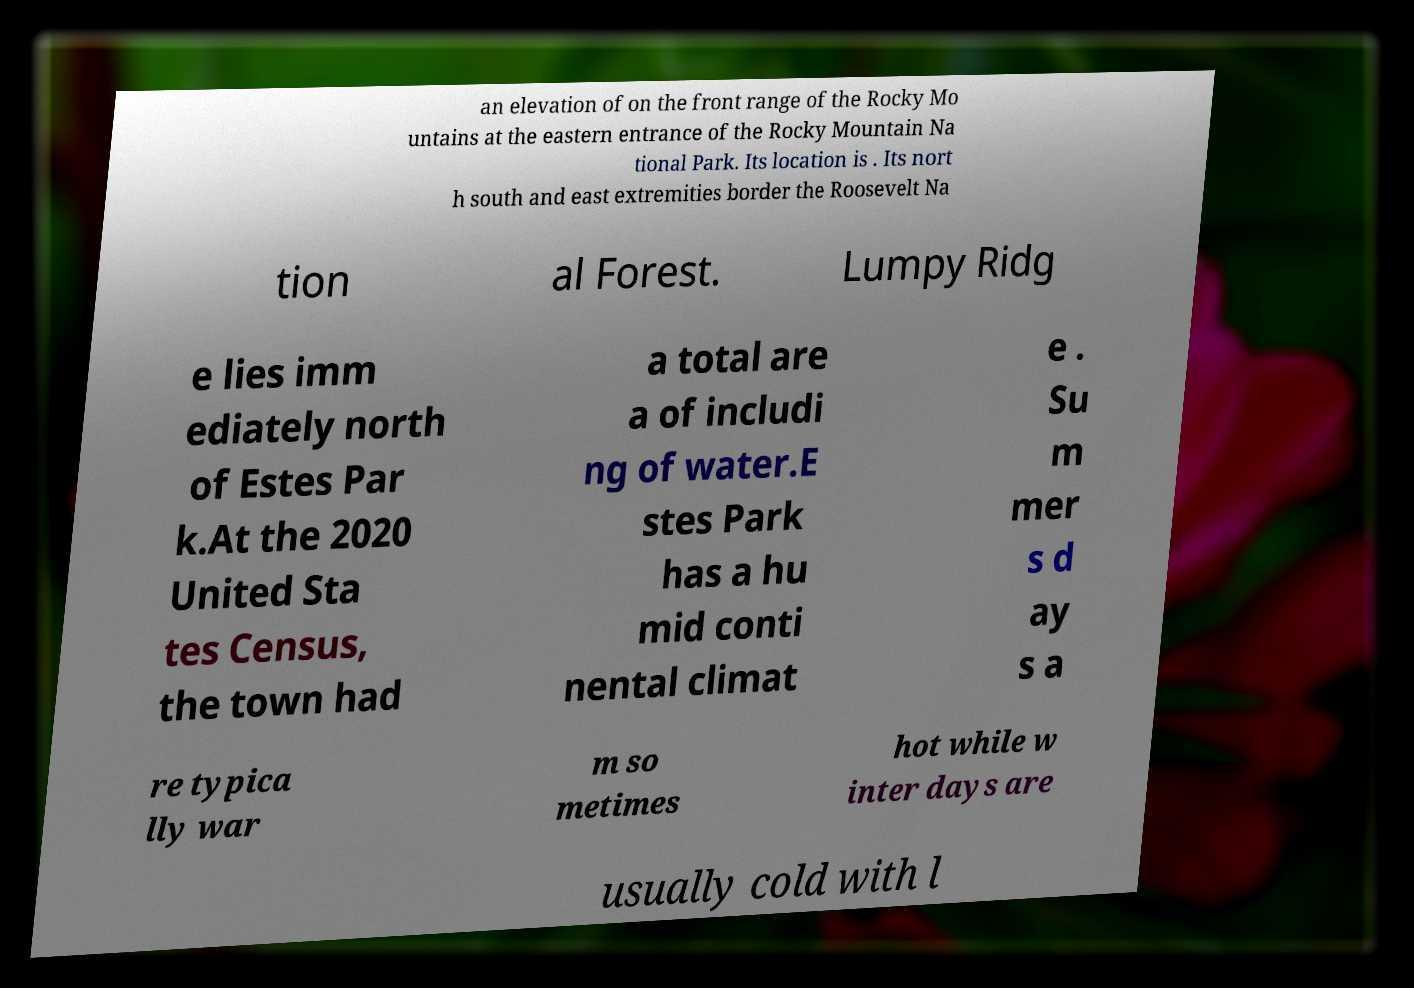What messages or text are displayed in this image? I need them in a readable, typed format. an elevation of on the front range of the Rocky Mo untains at the eastern entrance of the Rocky Mountain Na tional Park. Its location is . Its nort h south and east extremities border the Roosevelt Na tion al Forest. Lumpy Ridg e lies imm ediately north of Estes Par k.At the 2020 United Sta tes Census, the town had a total are a of includi ng of water.E stes Park has a hu mid conti nental climat e . Su m mer s d ay s a re typica lly war m so metimes hot while w inter days are usually cold with l 